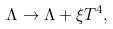Convert formula to latex. <formula><loc_0><loc_0><loc_500><loc_500>\Lambda \to \Lambda + \xi T ^ { 4 } ,</formula> 